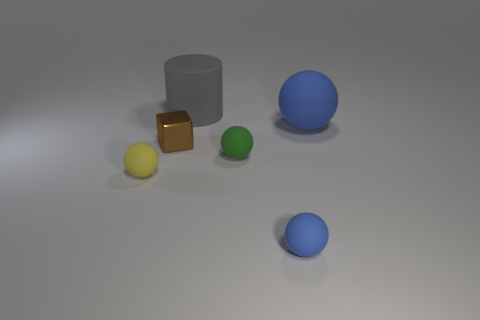Add 1 rubber cylinders. How many objects exist? 7 Subtract all small yellow rubber spheres. How many spheres are left? 3 Subtract 1 spheres. How many spheres are left? 3 Subtract all purple cubes. Subtract all gray cylinders. How many cubes are left? 1 Subtract all purple cylinders. How many purple blocks are left? 0 Subtract all green things. Subtract all blue things. How many objects are left? 3 Add 4 small brown shiny objects. How many small brown shiny objects are left? 5 Add 2 brown rubber things. How many brown rubber things exist? 2 Subtract all yellow balls. How many balls are left? 3 Subtract 0 yellow cylinders. How many objects are left? 6 